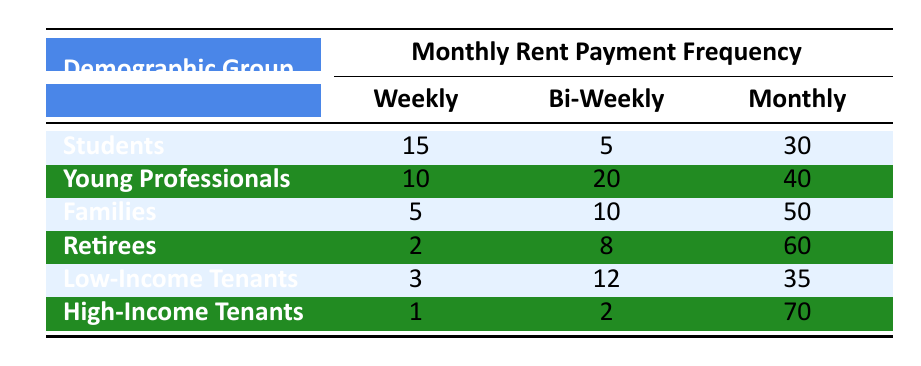What is the total number of tenants who prefer a monthly payment schedule? To find the total number of tenants preferring monthly payments, we look at the 'Monthly' column under each demographic group. The values are: 30 (Students) + 40 (Young Professionals) + 50 (Families) + 60 (Retirees) + 35 (Low-Income Tenants) + 70 (High-Income Tenants). Adding these together gives 30 + 40 + 50 + 60 + 35 + 70 = 285.
Answer: 285 Which demographic group has the highest frequency of weekly rent payments? By checking the 'Weekly' column in the table, we identify the frequencies: 15 (Students), 10 (Young Professionals), 5 (Families), 2 (Retirees), 3 (Low-Income Tenants), and 1 (High-Income Tenants). The highest frequency is 15 from the Students group.
Answer: Students What is the difference in the number of bi-weekly payments between Young Professionals and Low-Income Tenants? In the 'Bi-Weekly' column, the Young Professionals have a frequency of 20, while Low-Income Tenants have 12. The difference can be calculated as 20 - 12 = 8.
Answer: 8 Do more Families prefer monthly payments than Low-Income Tenants? Looking at the 'Monthly' payments, Families have a total of 50 while Low-Income Tenants have 35. Since 50 is greater than 35, the statement is true.
Answer: Yes What is the average frequency of weekly payments across all demographic groups? We sum the 'Weekly' payment frequencies: 15 (Students) + 10 (Young Professionals) + 5 (Families) + 2 (Retirees) + 3 (Low-Income Tenants) + 1 (High-Income Tenants) = 36. Since there are 6 groups, we divide 36 by 6 to find the average, which is 36 / 6 = 6.
Answer: 6 Which demographic group has the highest overall rent payment frequency? To find this, we need to sum all frequencies for each demographic group: Students (15 + 5 + 30 = 50), Young Professionals (10 + 20 + 40 = 70), Families (5 + 10 + 50 = 65), Retirees (2 + 8 + 60 = 70), Low-Income Tenants (3 + 12 + 35 = 50), and High-Income Tenants (1 + 2 + 70 = 73). The highest total is 73 from High-Income Tenants.
Answer: High-Income Tenants 